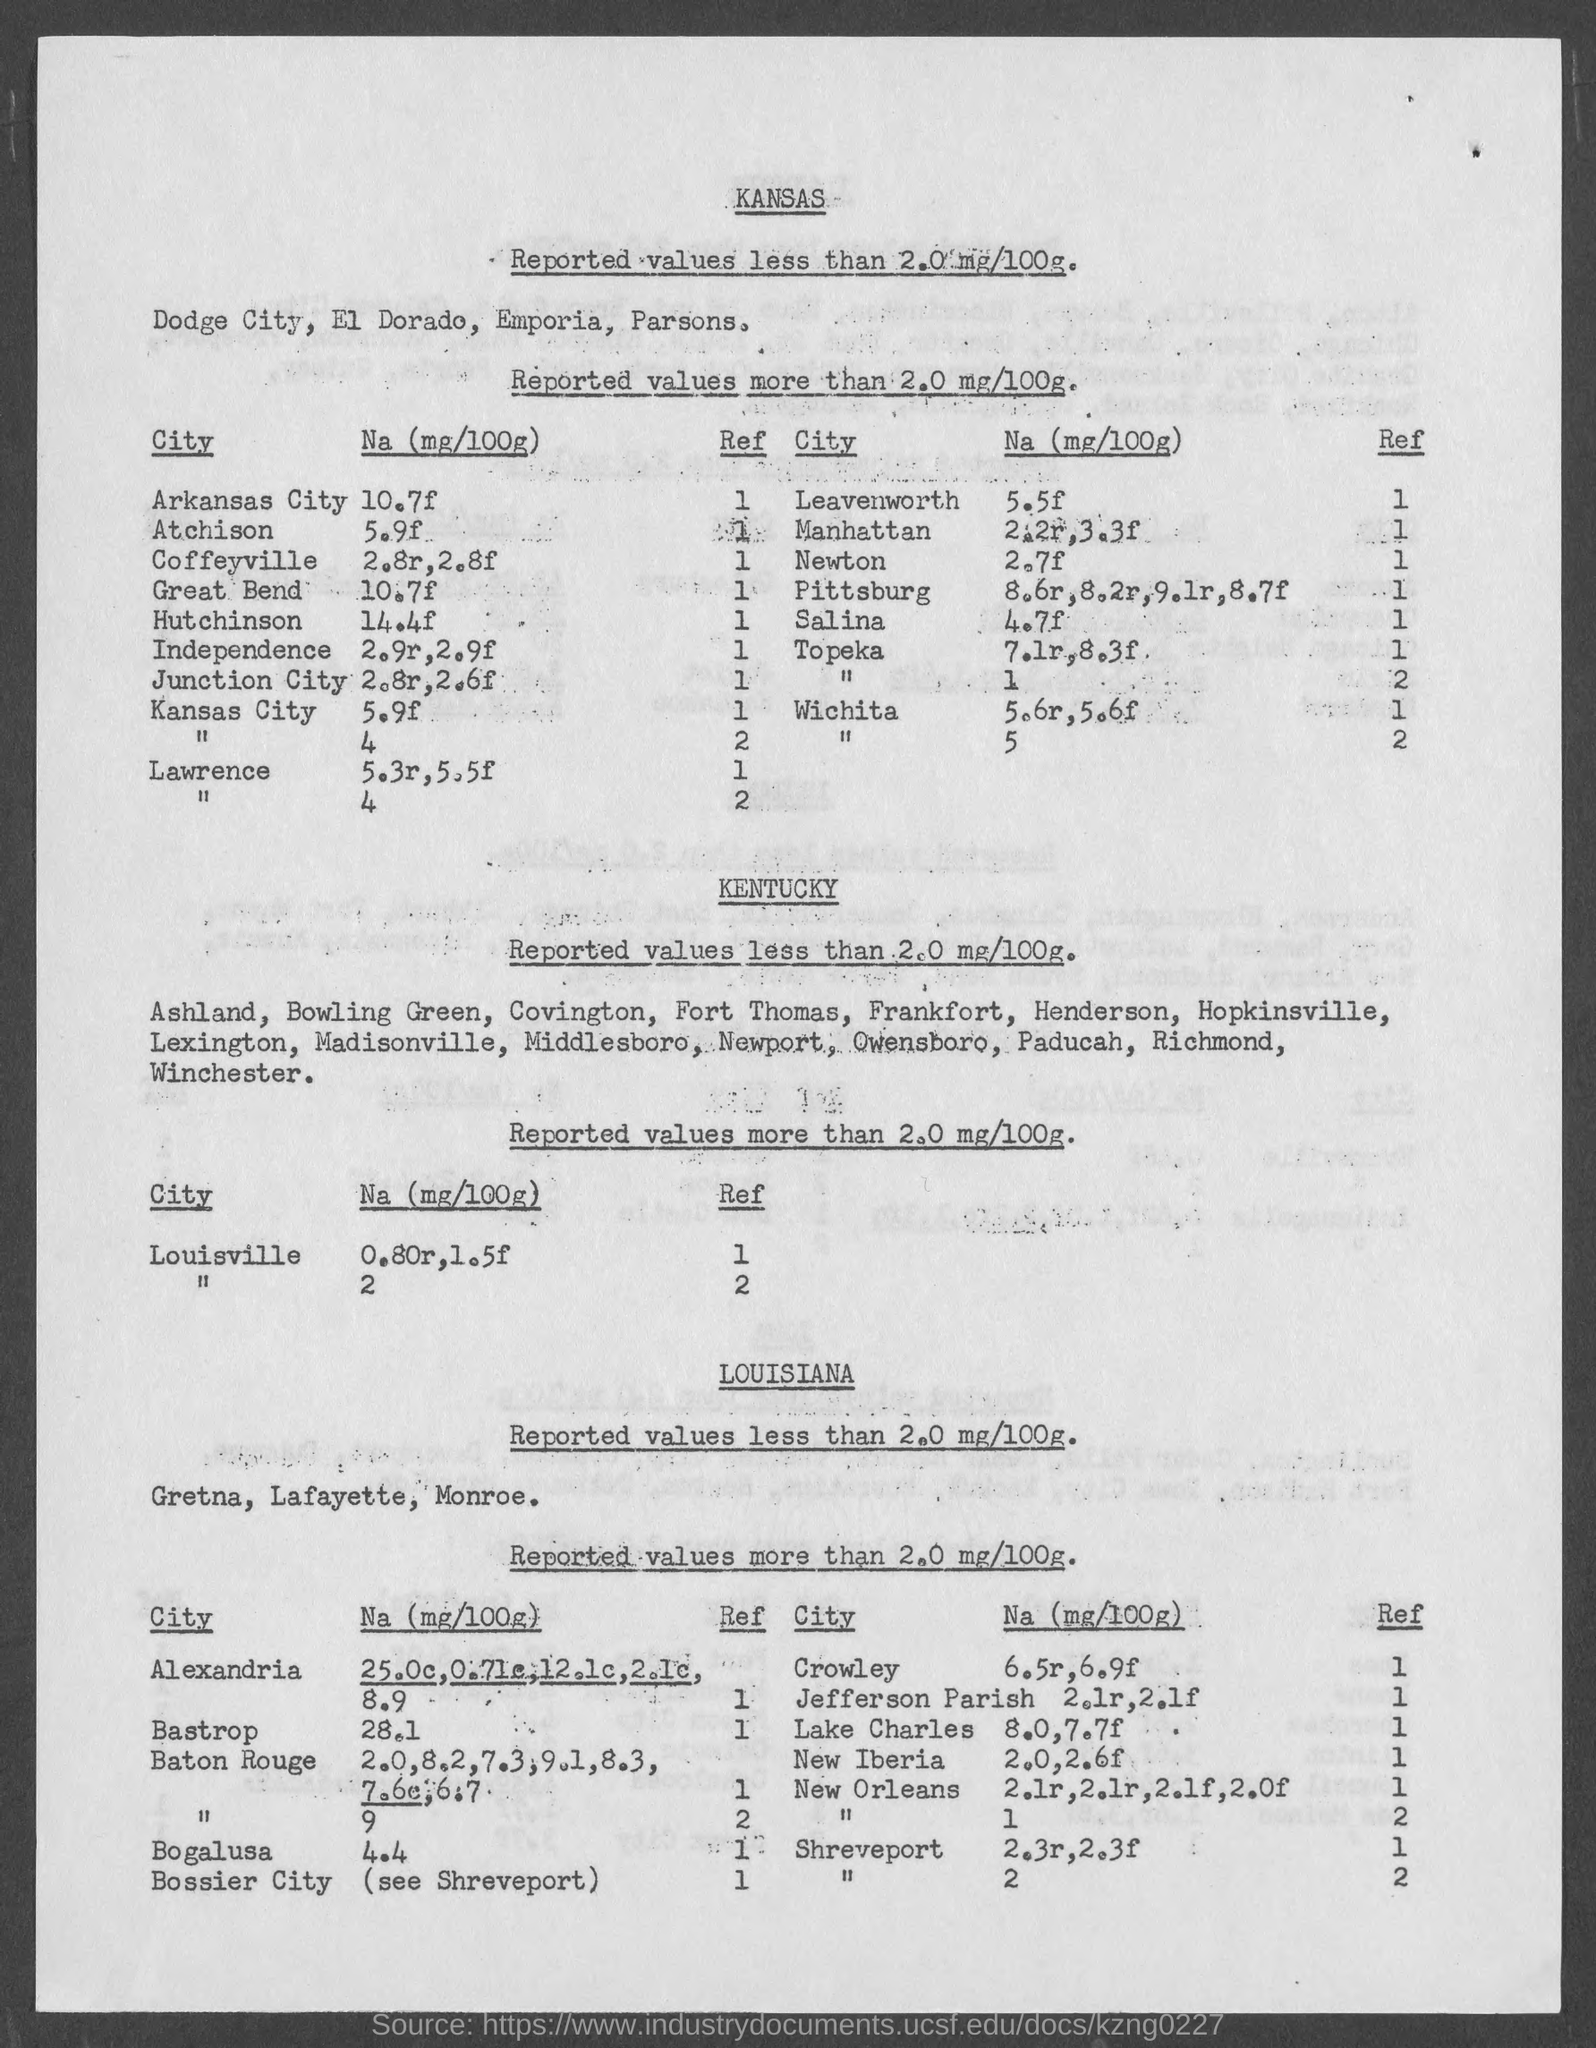What is na(mg/100g) in arkansas city?
Give a very brief answer. 10.7f. What is na(mg/100g) in atchison ?
Provide a succinct answer. 5.9f. What is na(mg/100g) in  great bend ?
Your response must be concise. 10.7f. What is na(mg/100g) in kansas city?
Offer a very short reply. 5.9f. What is na(mg/100g) in leavenworth ?
Make the answer very short. 5.5f. What is na(mg/100g) in newton?
Make the answer very short. 2.7f. What is na(mg/100g) in salina?
Ensure brevity in your answer.  4.7f. 